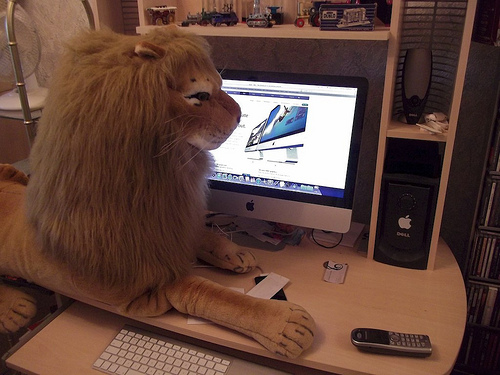<image>
Is the lion above the desk? No. The lion is not positioned above the desk. The vertical arrangement shows a different relationship. 